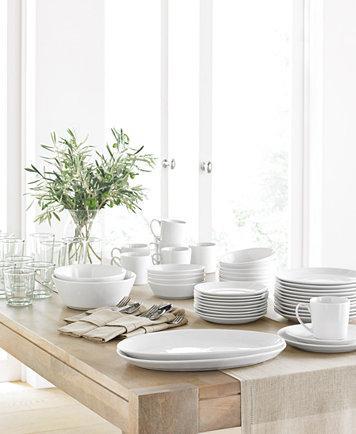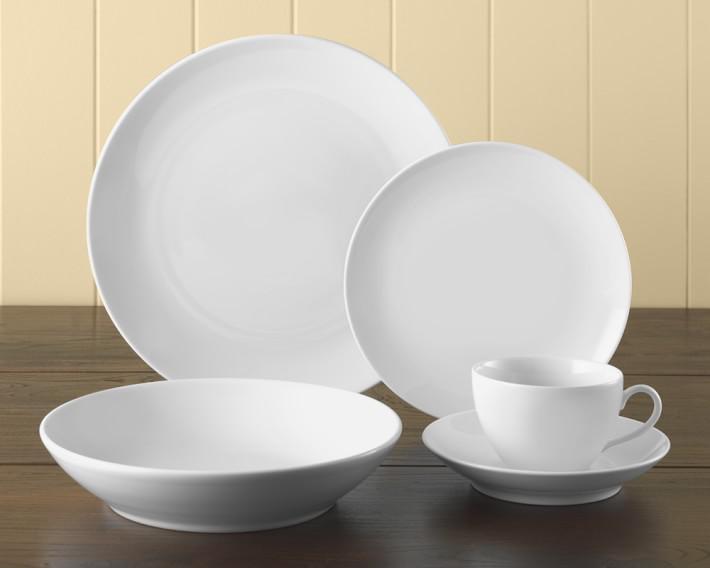The first image is the image on the left, the second image is the image on the right. Analyze the images presented: Is the assertion "There is all white dish with at least one thing green." valid? Answer yes or no. Yes. The first image is the image on the left, the second image is the image on the right. Assess this claim about the two images: "There are plates stacked together in exactly one image.". Correct or not? Answer yes or no. Yes. 